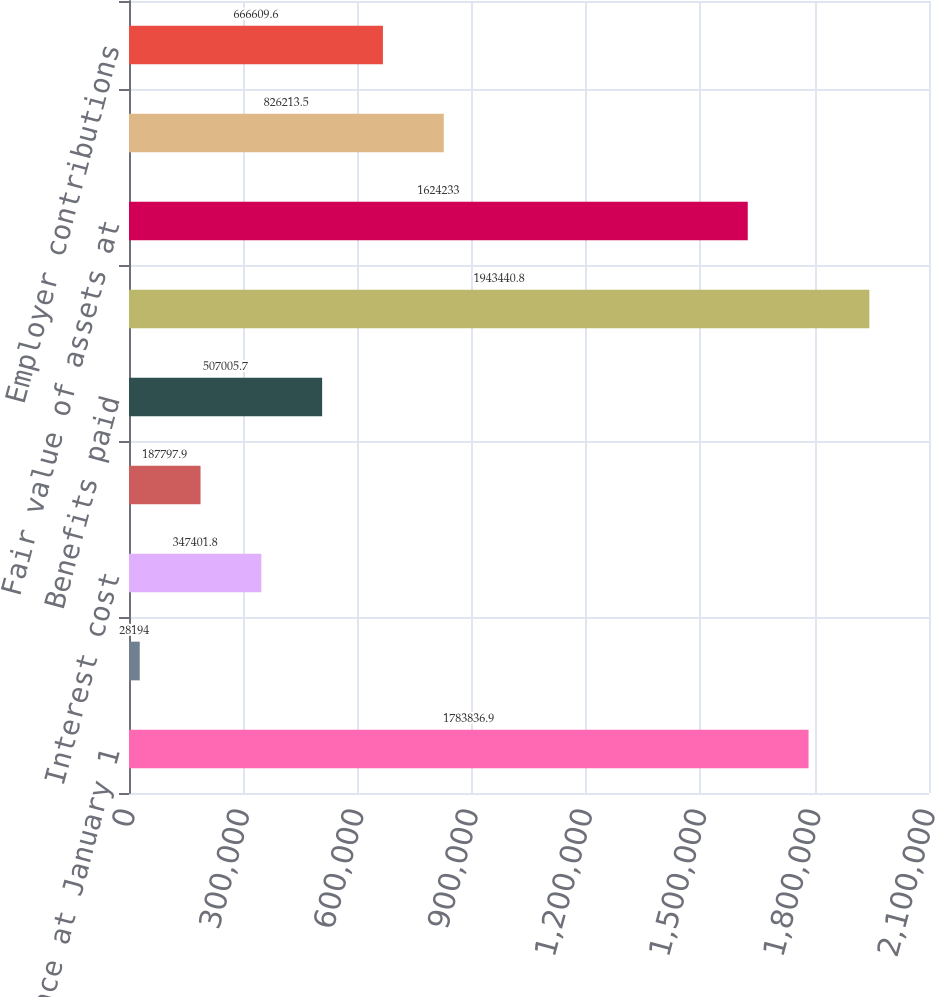<chart> <loc_0><loc_0><loc_500><loc_500><bar_chart><fcel>Balance at January 1<fcel>Service cost<fcel>Interest cost<fcel>Actuarial (gain)/loss<fcel>Benefits paid<fcel>Balance at December 31<fcel>Fair value of assets at<fcel>Actual return on plan assets<fcel>Employer contributions<nl><fcel>1.78384e+06<fcel>28194<fcel>347402<fcel>187798<fcel>507006<fcel>1.94344e+06<fcel>1.62423e+06<fcel>826214<fcel>666610<nl></chart> 